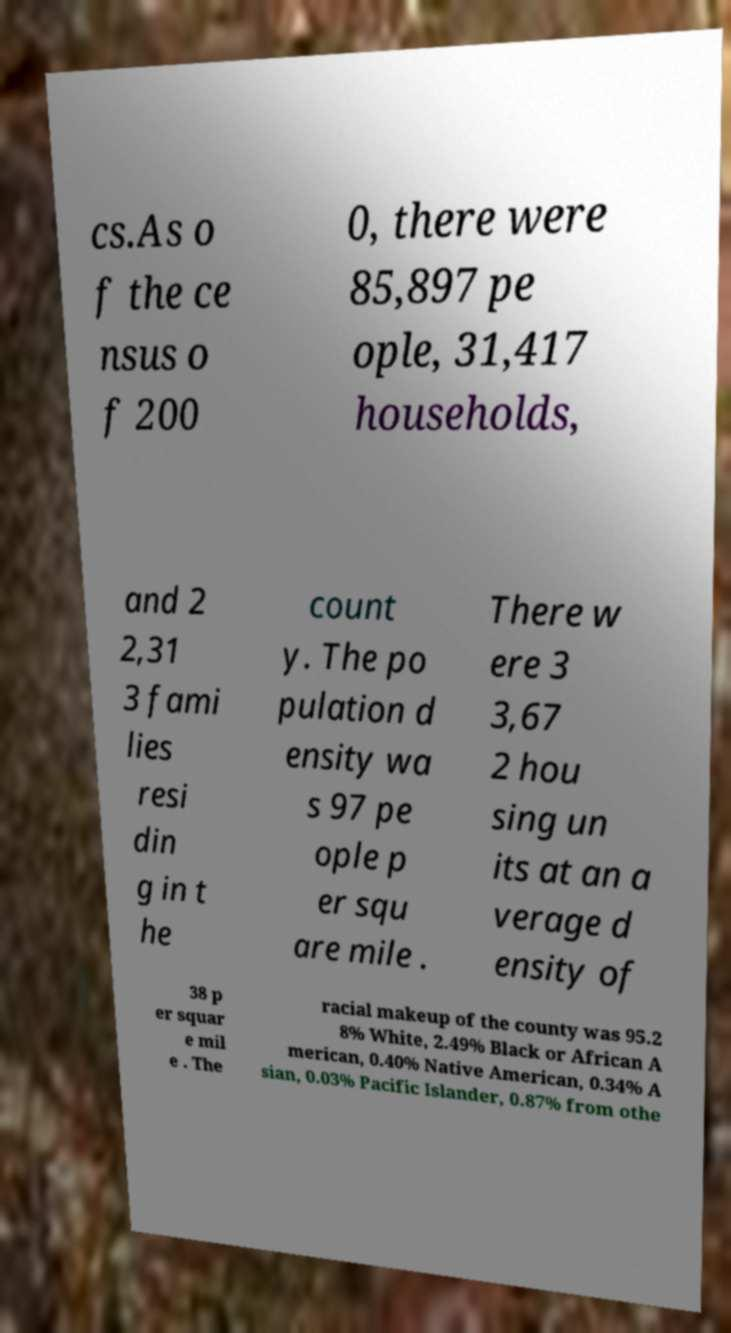Please read and relay the text visible in this image. What does it say? cs.As o f the ce nsus o f 200 0, there were 85,897 pe ople, 31,417 households, and 2 2,31 3 fami lies resi din g in t he count y. The po pulation d ensity wa s 97 pe ople p er squ are mile . There w ere 3 3,67 2 hou sing un its at an a verage d ensity of 38 p er squar e mil e . The racial makeup of the county was 95.2 8% White, 2.49% Black or African A merican, 0.40% Native American, 0.34% A sian, 0.03% Pacific Islander, 0.87% from othe 